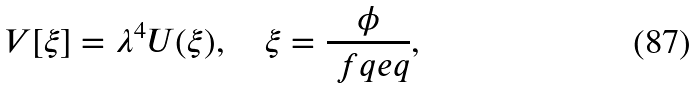Convert formula to latex. <formula><loc_0><loc_0><loc_500><loc_500>V [ \xi ] = \lambda ^ { 4 } U ( \xi ) , \quad \xi = \frac { \phi } { \ f q e q } ,</formula> 